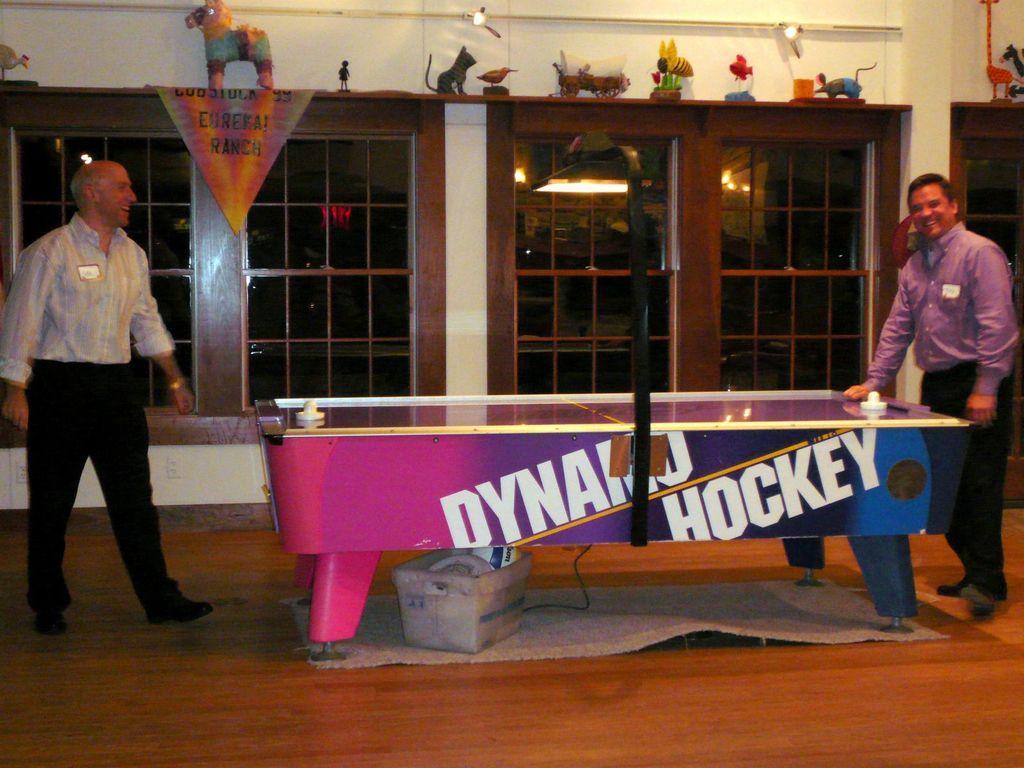Describe this image in one or two sentences. In this image, two peoples are standing near the table. They are smiling. Background, there is windows. Glass windows and top of the window we can see few toys are placed. In the bottom, there is a wooden floor, mat, some basket, few balls are there on it. 